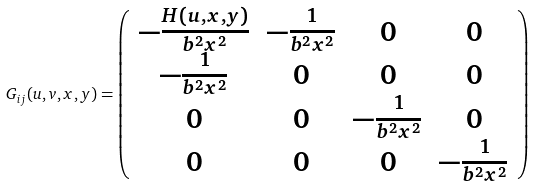Convert formula to latex. <formula><loc_0><loc_0><loc_500><loc_500>G _ { i j } ( u , v , x , y ) = \left ( \begin{array} { c c c c } - \frac { H ( u , x , y ) } { b ^ { 2 } x ^ { 2 } } & - \frac { 1 } { b ^ { 2 } x ^ { 2 } } & 0 & 0 \\ - \frac { 1 } { b ^ { 2 } x ^ { 2 } } & 0 & 0 & 0 \\ 0 & 0 & - \frac { 1 } { b ^ { 2 } x ^ { 2 } } & 0 \\ 0 & 0 & 0 & - \frac { 1 } { b ^ { 2 } x ^ { 2 } } \end{array} \right )</formula> 